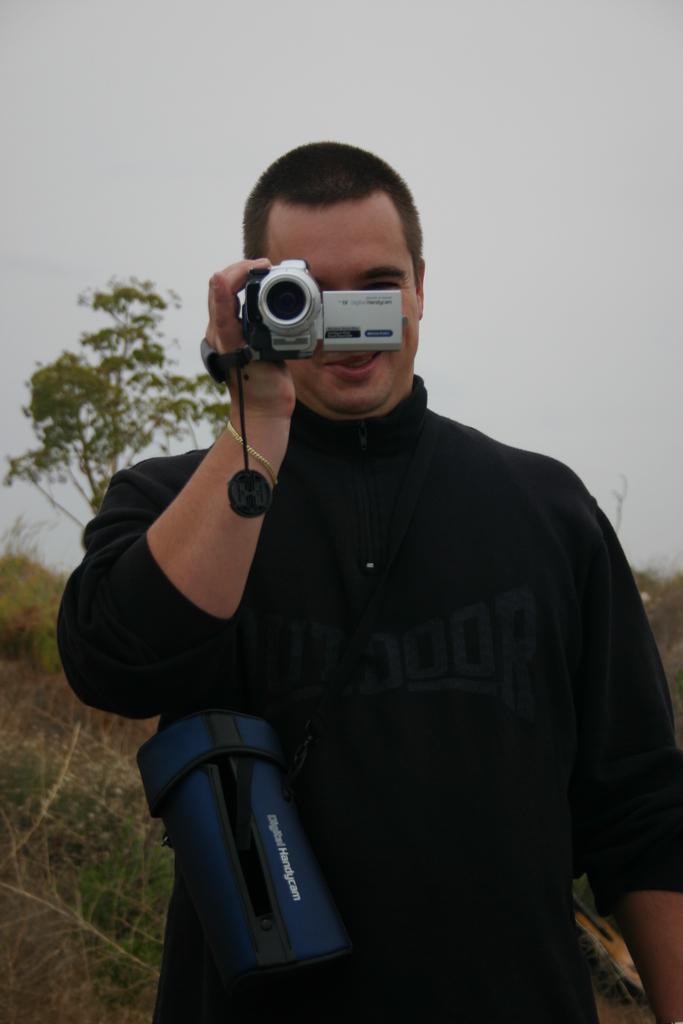Please provide a concise description of this image. On the background we can see sky, trees. We can see a man standing and holding a camera in his hands and recording. This is a bag in blue colour 